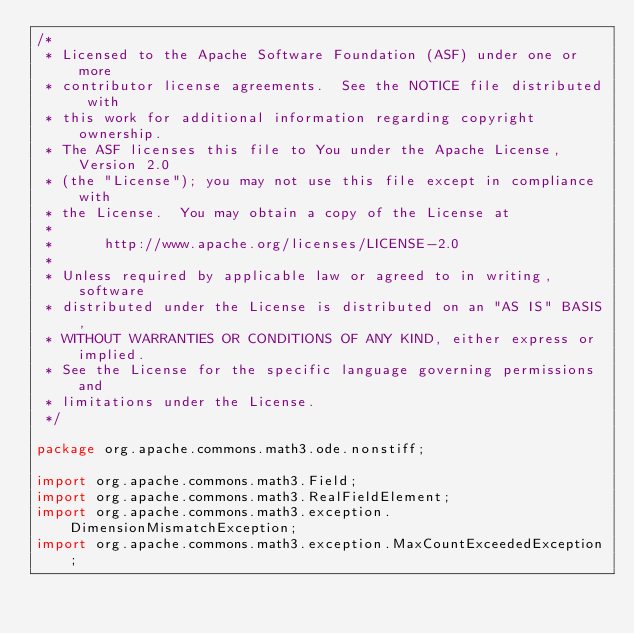Convert code to text. <code><loc_0><loc_0><loc_500><loc_500><_Java_>/*
 * Licensed to the Apache Software Foundation (ASF) under one or more
 * contributor license agreements.  See the NOTICE file distributed with
 * this work for additional information regarding copyright ownership.
 * The ASF licenses this file to You under the Apache License, Version 2.0
 * (the "License"); you may not use this file except in compliance with
 * the License.  You may obtain a copy of the License at
 *
 *      http://www.apache.org/licenses/LICENSE-2.0
 *
 * Unless required by applicable law or agreed to in writing, software
 * distributed under the License is distributed on an "AS IS" BASIS,
 * WITHOUT WARRANTIES OR CONDITIONS OF ANY KIND, either express or implied.
 * See the License for the specific language governing permissions and
 * limitations under the License.
 */

package org.apache.commons.math3.ode.nonstiff;

import org.apache.commons.math3.Field;
import org.apache.commons.math3.RealFieldElement;
import org.apache.commons.math3.exception.DimensionMismatchException;
import org.apache.commons.math3.exception.MaxCountExceededException;</code> 